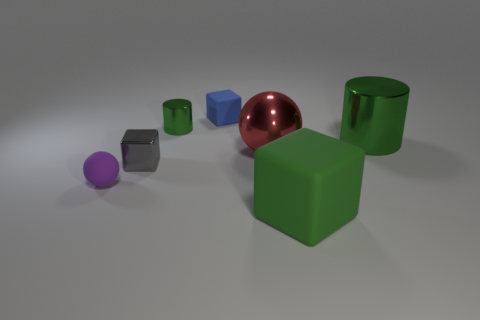Subtract all green cubes. How many cubes are left? 2 Add 1 small cylinders. How many objects exist? 8 Subtract all gray blocks. How many blocks are left? 2 Subtract all blocks. How many objects are left? 4 Subtract all gray spheres. How many red cylinders are left? 0 Subtract all small things. Subtract all small green metallic things. How many objects are left? 2 Add 1 big red balls. How many big red balls are left? 2 Add 7 large brown matte cylinders. How many large brown matte cylinders exist? 7 Subtract 0 purple cylinders. How many objects are left? 7 Subtract 1 blocks. How many blocks are left? 2 